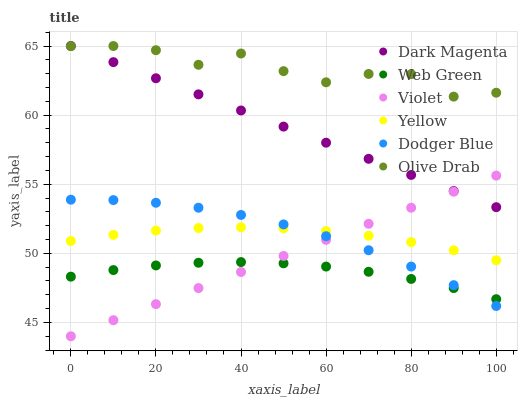Does Web Green have the minimum area under the curve?
Answer yes or no. Yes. Does Olive Drab have the maximum area under the curve?
Answer yes or no. Yes. Does Yellow have the minimum area under the curve?
Answer yes or no. No. Does Yellow have the maximum area under the curve?
Answer yes or no. No. Is Violet the smoothest?
Answer yes or no. Yes. Is Olive Drab the roughest?
Answer yes or no. Yes. Is Yellow the smoothest?
Answer yes or no. No. Is Yellow the roughest?
Answer yes or no. No. Does Violet have the lowest value?
Answer yes or no. Yes. Does Yellow have the lowest value?
Answer yes or no. No. Does Olive Drab have the highest value?
Answer yes or no. Yes. Does Yellow have the highest value?
Answer yes or no. No. Is Yellow less than Dark Magenta?
Answer yes or no. Yes. Is Olive Drab greater than Yellow?
Answer yes or no. Yes. Does Yellow intersect Violet?
Answer yes or no. Yes. Is Yellow less than Violet?
Answer yes or no. No. Is Yellow greater than Violet?
Answer yes or no. No. Does Yellow intersect Dark Magenta?
Answer yes or no. No. 